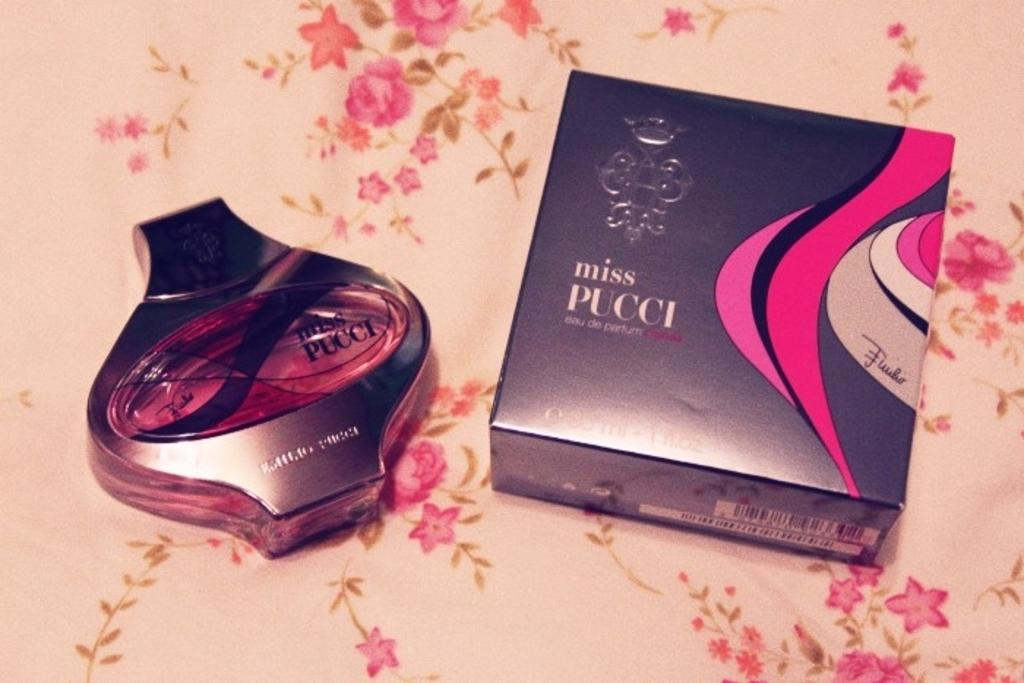<image>
Render a clear and concise summary of the photo. A container of parfum with the box next to it with Miss Pucci on it. 